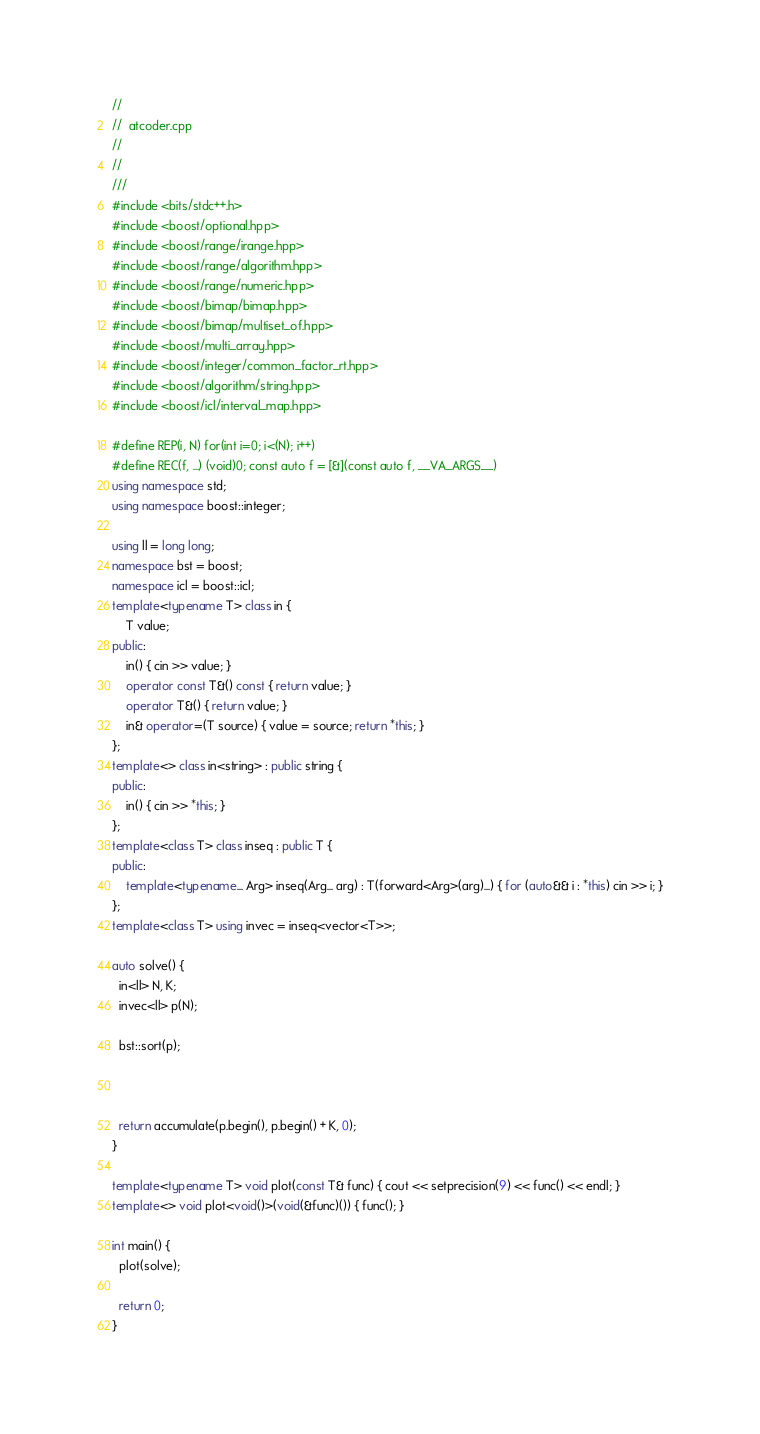Convert code to text. <code><loc_0><loc_0><loc_500><loc_500><_C++_>//
//  atcoder.cpp
//
//
///
#include <bits/stdc++.h>
#include <boost/optional.hpp>
#include <boost/range/irange.hpp>
#include <boost/range/algorithm.hpp>
#include <boost/range/numeric.hpp>
#include <boost/bimap/bimap.hpp>
#include <boost/bimap/multiset_of.hpp>
#include <boost/multi_array.hpp>
#include <boost/integer/common_factor_rt.hpp>
#include <boost/algorithm/string.hpp>
#include <boost/icl/interval_map.hpp>

#define REP(i, N) for(int i=0; i<(N); i++)
#define REC(f, ...) (void)0; const auto f = [&](const auto f, __VA_ARGS__)
using namespace std;
using namespace boost::integer;

using ll = long long;
namespace bst = boost;
namespace icl = boost::icl;
template<typename T> class in {
    T value;
public:
    in() { cin >> value; }
    operator const T&() const { return value; }
    operator T&() { return value; }
    in& operator=(T source) { value = source; return *this; }
};
template<> class in<string> : public string {
public:
    in() { cin >> *this; }
};
template<class T> class inseq : public T {
public:
    template<typename... Arg> inseq(Arg... arg) : T(forward<Arg>(arg)...) { for (auto&& i : *this) cin >> i; }
};
template<class T> using invec = inseq<vector<T>>;

auto solve() {
  in<ll> N, K;
  invec<ll> p(N);
  
  bst::sort(p);
  


  return accumulate(p.begin(), p.begin() + K, 0);
}

template<typename T> void plot(const T& func) { cout << setprecision(9) << func() << endl; }
template<> void plot<void()>(void(&func)()) { func(); }

int main() {
  plot(solve);

  return 0;
}

</code> 